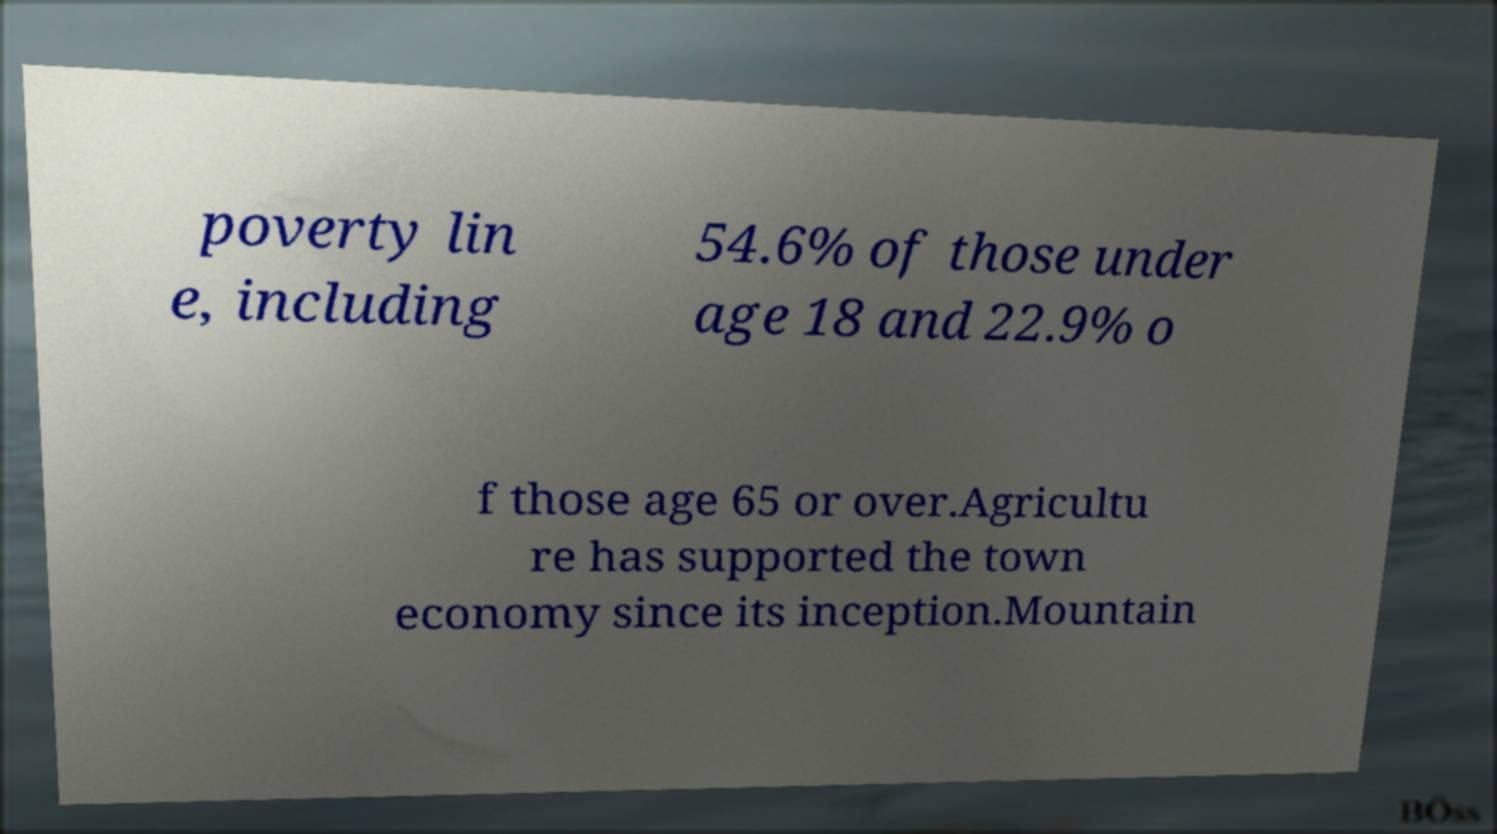I need the written content from this picture converted into text. Can you do that? poverty lin e, including 54.6% of those under age 18 and 22.9% o f those age 65 or over.Agricultu re has supported the town economy since its inception.Mountain 